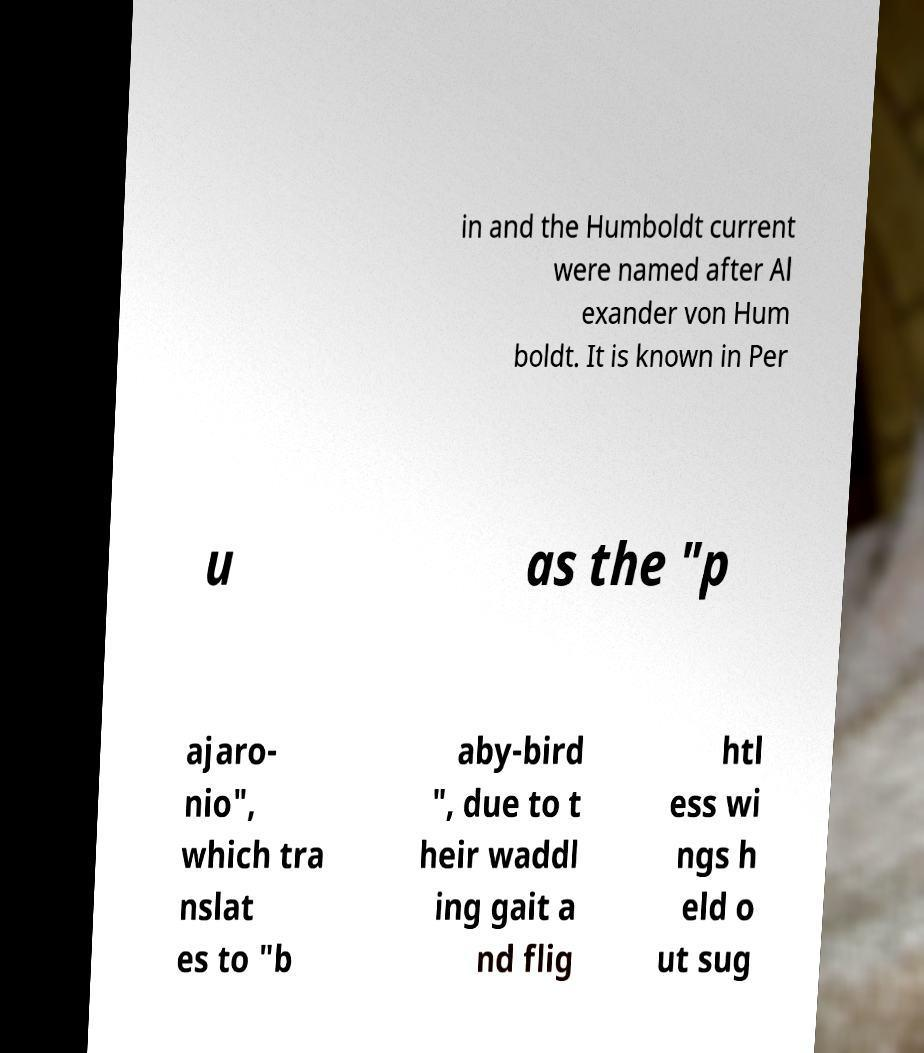There's text embedded in this image that I need extracted. Can you transcribe it verbatim? in and the Humboldt current were named after Al exander von Hum boldt. It is known in Per u as the "p ajaro- nio", which tra nslat es to "b aby-bird ", due to t heir waddl ing gait a nd flig htl ess wi ngs h eld o ut sug 